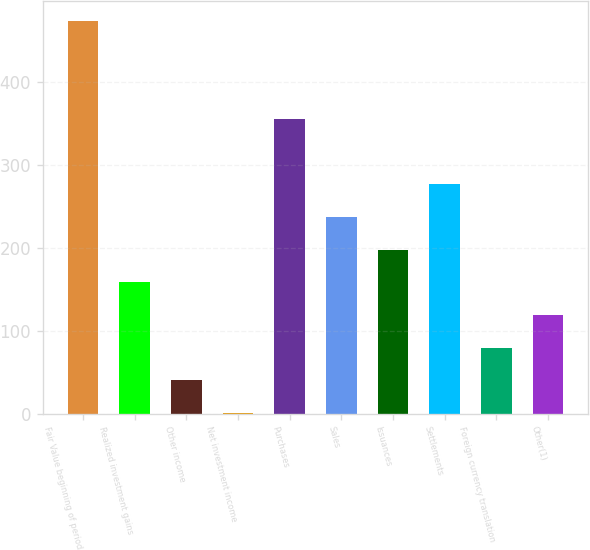Convert chart. <chart><loc_0><loc_0><loc_500><loc_500><bar_chart><fcel>Fair Value beginning of period<fcel>Realized investment gains<fcel>Other income<fcel>Net investment income<fcel>Purchases<fcel>Sales<fcel>Issuances<fcel>Settlements<fcel>Foreign currency translation<fcel>Other(1)<nl><fcel>473.8<fcel>158.6<fcel>40.4<fcel>1<fcel>355.6<fcel>237.4<fcel>198<fcel>276.8<fcel>79.8<fcel>119.2<nl></chart> 